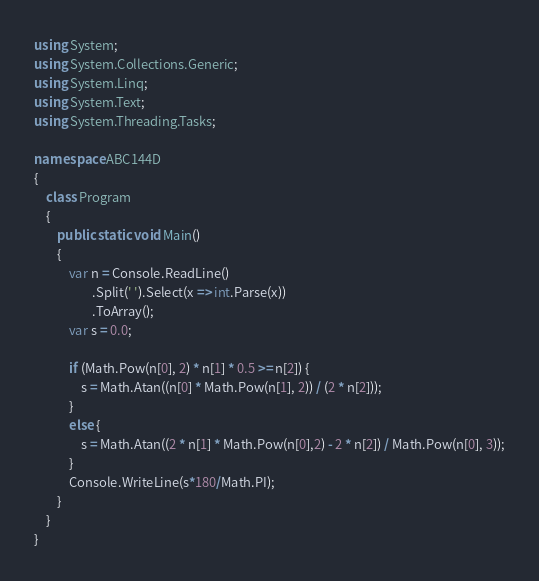Convert code to text. <code><loc_0><loc_0><loc_500><loc_500><_C#_>using System;
using System.Collections.Generic;
using System.Linq;
using System.Text;
using System.Threading.Tasks;

namespace ABC144D
{
    class Program
    {
        public static void Main()
        {
            var n = Console.ReadLine()
                    .Split(' ').Select(x => int.Parse(x))
                    .ToArray();
            var s = 0.0;

            if (Math.Pow(n[0], 2) * n[1] * 0.5 >= n[2]) {
                s = Math.Atan((n[0] * Math.Pow(n[1], 2)) / (2 * n[2]));    
            }
            else {
                s = Math.Atan((2 * n[1] * Math.Pow(n[0],2) - 2 * n[2]) / Math.Pow(n[0], 3));
            }
            Console.WriteLine(s*180/Math.PI);
        }
    }
}
</code> 